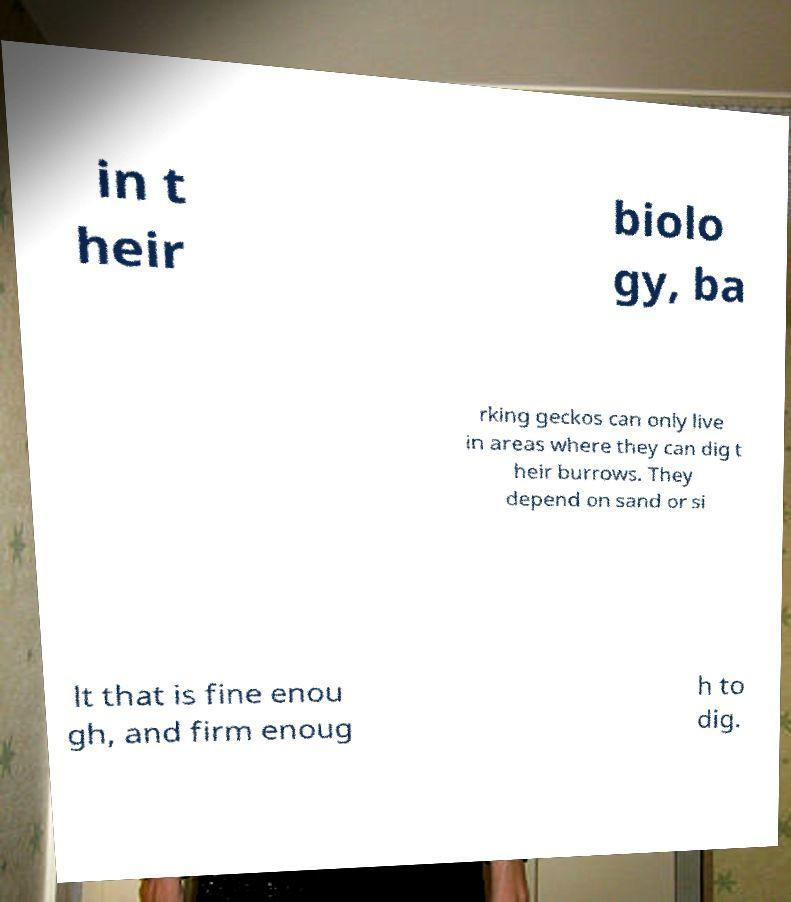Please identify and transcribe the text found in this image. in t heir biolo gy, ba rking geckos can only live in areas where they can dig t heir burrows. They depend on sand or si lt that is fine enou gh, and firm enoug h to dig. 